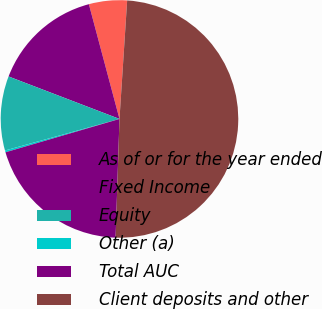<chart> <loc_0><loc_0><loc_500><loc_500><pie_chart><fcel>As of or for the year ended<fcel>Fixed Income<fcel>Equity<fcel>Other (a)<fcel>Total AUC<fcel>Client deposits and other<nl><fcel>5.18%<fcel>15.03%<fcel>10.1%<fcel>0.25%<fcel>19.95%<fcel>49.49%<nl></chart> 